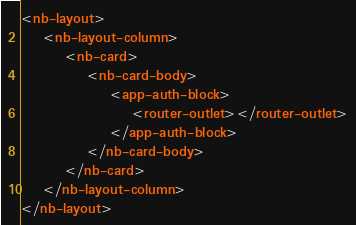Convert code to text. <code><loc_0><loc_0><loc_500><loc_500><_HTML_><nb-layout>
    <nb-layout-column>
        <nb-card>
            <nb-card-body>
                <app-auth-block>
                    <router-outlet></router-outlet>
                </app-auth-block>
            </nb-card-body>
        </nb-card>
    </nb-layout-column>
</nb-layout></code> 